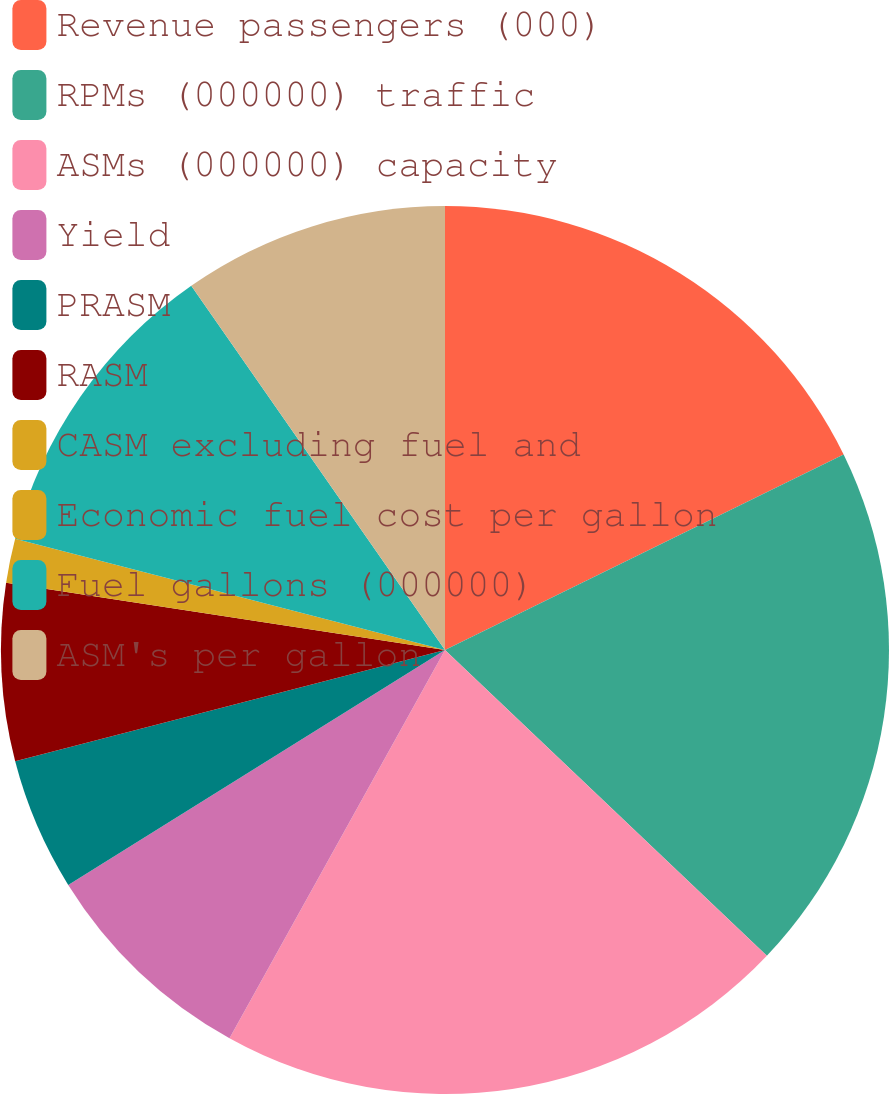Convert chart. <chart><loc_0><loc_0><loc_500><loc_500><pie_chart><fcel>Revenue passengers (000)<fcel>RPMs (000000) traffic<fcel>ASMs (000000) capacity<fcel>Yield<fcel>PRASM<fcel>RASM<fcel>CASM excluding fuel and<fcel>Economic fuel cost per gallon<fcel>Fuel gallons (000000)<fcel>ASM's per gallon<nl><fcel>17.74%<fcel>19.35%<fcel>20.97%<fcel>8.06%<fcel>4.84%<fcel>6.45%<fcel>1.61%<fcel>0.0%<fcel>11.29%<fcel>9.68%<nl></chart> 